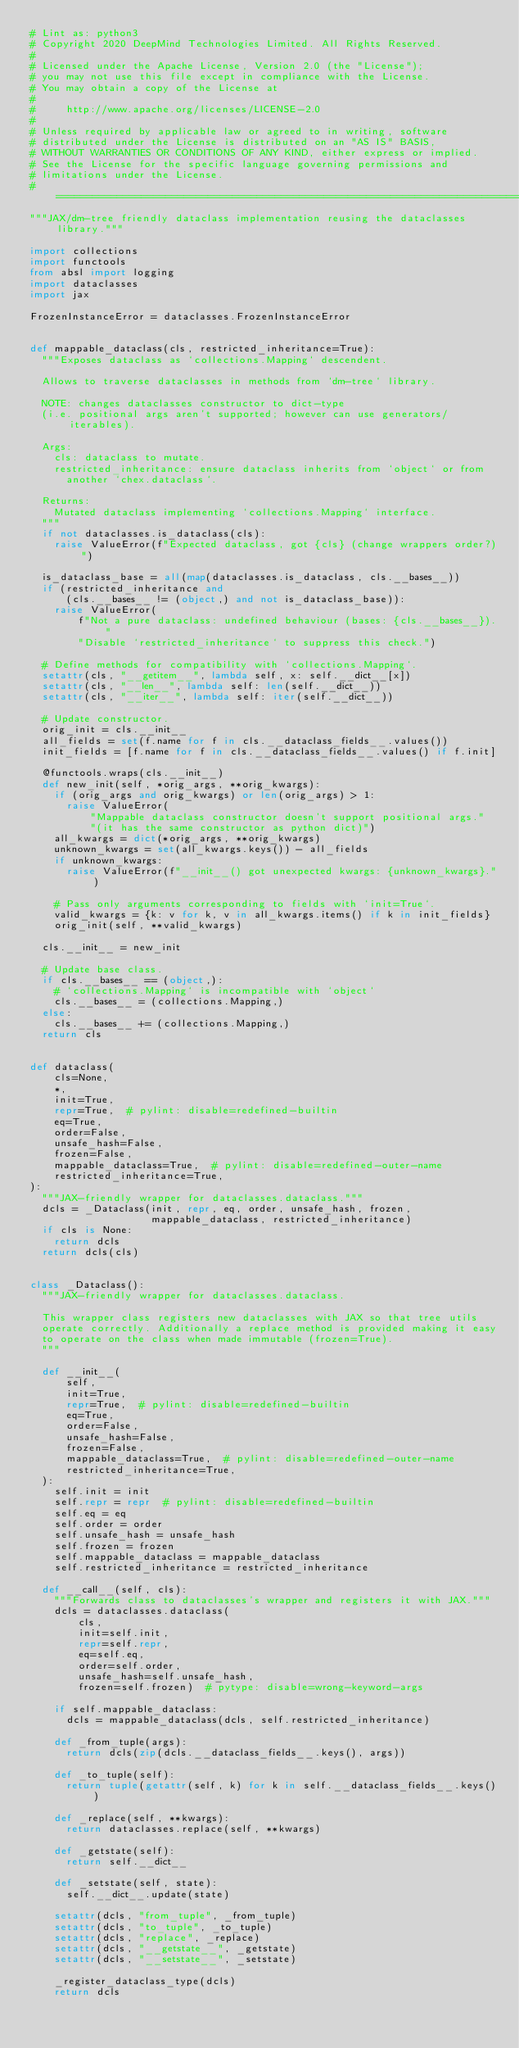<code> <loc_0><loc_0><loc_500><loc_500><_Python_># Lint as: python3
# Copyright 2020 DeepMind Technologies Limited. All Rights Reserved.
#
# Licensed under the Apache License, Version 2.0 (the "License");
# you may not use this file except in compliance with the License.
# You may obtain a copy of the License at
#
#     http://www.apache.org/licenses/LICENSE-2.0
#
# Unless required by applicable law or agreed to in writing, software
# distributed under the License is distributed on an "AS IS" BASIS,
# WITHOUT WARRANTIES OR CONDITIONS OF ANY KIND, either express or implied.
# See the License for the specific language governing permissions and
# limitations under the License.
# ==============================================================================
"""JAX/dm-tree friendly dataclass implementation reusing the dataclasses library."""

import collections
import functools
from absl import logging
import dataclasses
import jax

FrozenInstanceError = dataclasses.FrozenInstanceError


def mappable_dataclass(cls, restricted_inheritance=True):
  """Exposes dataclass as `collections.Mapping` descendent.

  Allows to traverse dataclasses in methods from `dm-tree` library.

  NOTE: changes dataclasses constructor to dict-type
  (i.e. positional args aren't supported; however can use generators/iterables).

  Args:
    cls: dataclass to mutate.
    restricted_inheritance: ensure dataclass inherits from `object` or from
      another `chex.dataclass`.

  Returns:
    Mutated dataclass implementing `collections.Mapping` interface.
  """
  if not dataclasses.is_dataclass(cls):
    raise ValueError(f"Expected dataclass, got {cls} (change wrappers order?)")

  is_dataclass_base = all(map(dataclasses.is_dataclass, cls.__bases__))
  if (restricted_inheritance and
      (cls.__bases__ != (object,) and not is_dataclass_base)):
    raise ValueError(
        f"Not a pure dataclass: undefined behaviour (bases: {cls.__bases__})."
        "Disable `restricted_inheritance` to suppress this check.")

  # Define methods for compatibility with `collections.Mapping`.
  setattr(cls, "__getitem__", lambda self, x: self.__dict__[x])
  setattr(cls, "__len__", lambda self: len(self.__dict__))
  setattr(cls, "__iter__", lambda self: iter(self.__dict__))

  # Update constructor.
  orig_init = cls.__init__
  all_fields = set(f.name for f in cls.__dataclass_fields__.values())
  init_fields = [f.name for f in cls.__dataclass_fields__.values() if f.init]

  @functools.wraps(cls.__init__)
  def new_init(self, *orig_args, **orig_kwargs):
    if (orig_args and orig_kwargs) or len(orig_args) > 1:
      raise ValueError(
          "Mappable dataclass constructor doesn't support positional args."
          "(it has the same constructor as python dict)")
    all_kwargs = dict(*orig_args, **orig_kwargs)
    unknown_kwargs = set(all_kwargs.keys()) - all_fields
    if unknown_kwargs:
      raise ValueError(f"__init__() got unexpected kwargs: {unknown_kwargs}.")

    # Pass only arguments corresponding to fields with `init=True`.
    valid_kwargs = {k: v for k, v in all_kwargs.items() if k in init_fields}
    orig_init(self, **valid_kwargs)

  cls.__init__ = new_init

  # Update base class.
  if cls.__bases__ == (object,):
    # `collections.Mapping` is incompatible with `object`
    cls.__bases__ = (collections.Mapping,)
  else:
    cls.__bases__ += (collections.Mapping,)
  return cls


def dataclass(
    cls=None,
    *,
    init=True,
    repr=True,  # pylint: disable=redefined-builtin
    eq=True,
    order=False,
    unsafe_hash=False,
    frozen=False,
    mappable_dataclass=True,  # pylint: disable=redefined-outer-name
    restricted_inheritance=True,
):
  """JAX-friendly wrapper for dataclasses.dataclass."""
  dcls = _Dataclass(init, repr, eq, order, unsafe_hash, frozen,
                    mappable_dataclass, restricted_inheritance)
  if cls is None:
    return dcls
  return dcls(cls)


class _Dataclass():
  """JAX-friendly wrapper for dataclasses.dataclass.

  This wrapper class registers new dataclasses with JAX so that tree utils
  operate correctly. Additionally a replace method is provided making it easy
  to operate on the class when made immutable (frozen=True).
  """

  def __init__(
      self,
      init=True,
      repr=True,  # pylint: disable=redefined-builtin
      eq=True,
      order=False,
      unsafe_hash=False,
      frozen=False,
      mappable_dataclass=True,  # pylint: disable=redefined-outer-name
      restricted_inheritance=True,
  ):
    self.init = init
    self.repr = repr  # pylint: disable=redefined-builtin
    self.eq = eq
    self.order = order
    self.unsafe_hash = unsafe_hash
    self.frozen = frozen
    self.mappable_dataclass = mappable_dataclass
    self.restricted_inheritance = restricted_inheritance

  def __call__(self, cls):
    """Forwards class to dataclasses's wrapper and registers it with JAX."""
    dcls = dataclasses.dataclass(
        cls,
        init=self.init,
        repr=self.repr,
        eq=self.eq,
        order=self.order,
        unsafe_hash=self.unsafe_hash,
        frozen=self.frozen)  # pytype: disable=wrong-keyword-args

    if self.mappable_dataclass:
      dcls = mappable_dataclass(dcls, self.restricted_inheritance)

    def _from_tuple(args):
      return dcls(zip(dcls.__dataclass_fields__.keys(), args))

    def _to_tuple(self):
      return tuple(getattr(self, k) for k in self.__dataclass_fields__.keys())

    def _replace(self, **kwargs):
      return dataclasses.replace(self, **kwargs)

    def _getstate(self):
      return self.__dict__

    def _setstate(self, state):
      self.__dict__.update(state)

    setattr(dcls, "from_tuple", _from_tuple)
    setattr(dcls, "to_tuple", _to_tuple)
    setattr(dcls, "replace", _replace)
    setattr(dcls, "__getstate__", _getstate)
    setattr(dcls, "__setstate__", _setstate)

    _register_dataclass_type(dcls)
    return dcls

</code> 